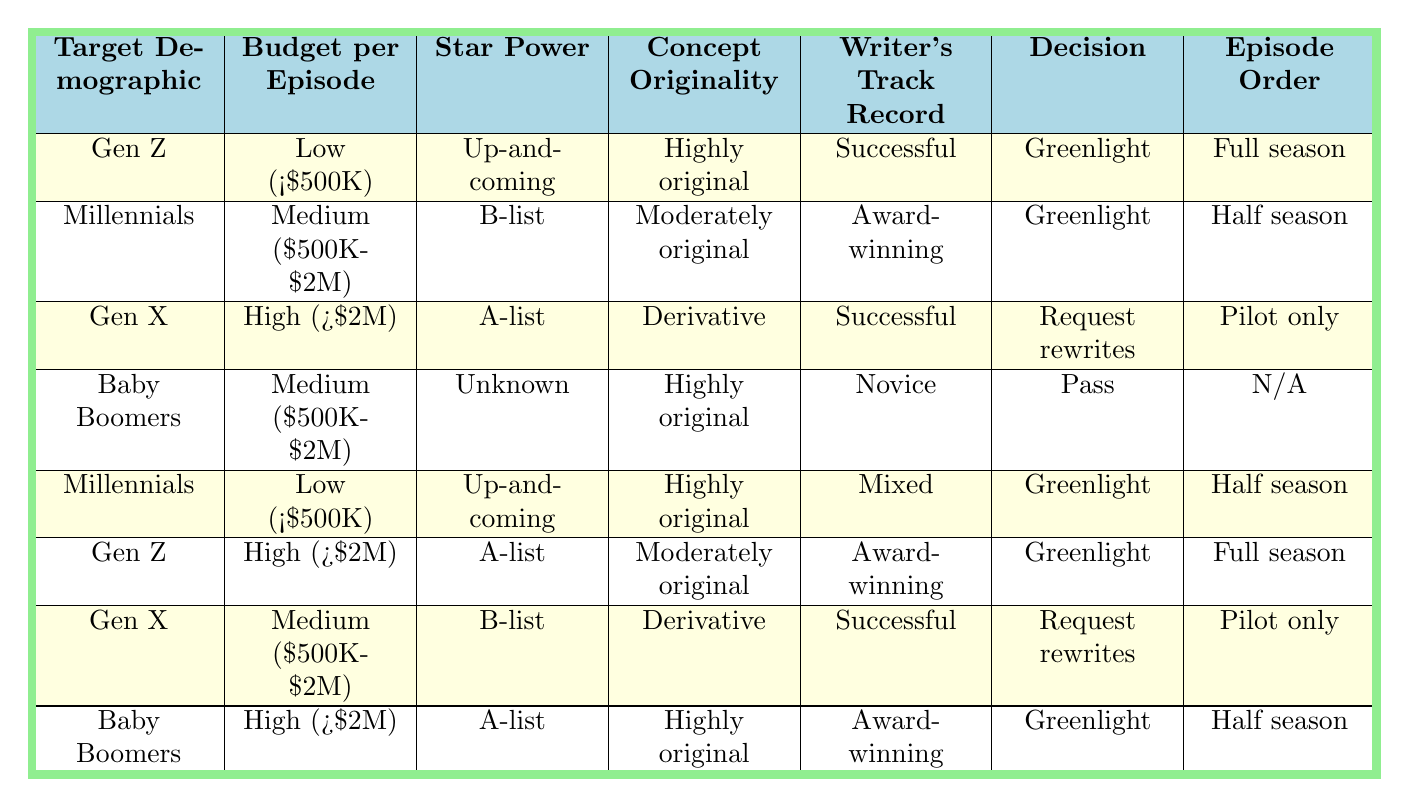What decision was made for comedies targeting Gen Z with a low budget and an up-and-coming star? The table shows that for Gen Z with a low budget, up-and-coming star, highly original concept, and a successful writer's track record, the decision was to greenlight a full season.
Answer: Greenlight, Full season How many different episode orders are associated with the Millennials demographic? By reviewing the table, we see that there are two episode orders associated with Millennials: "Half season" and "Pilot only." Even though the table specifies two different conditions, it points to the same episode order.
Answer: 2 Is there any comedy pilot that received a "Pass" as a decision? The table indicates that there is one situation where Baby Boomers with a medium budget, unknown star power, highly original concept, and novice writer's track record received a pass.
Answer: Yes What is the average budget category of comedies that received a "Greenlight"? Examining the rows for the "Greenlight" decision, we find two "Low," two "Medium," and three "High" budget instances. The average can be calculated as: (2 Low + 2 Medium + 3 High) / 7 = Medium, as the average tends towards the midpoint.
Answer: Medium Which demographic has the most combinations for "Request rewrites" decisions? Looking at the table, we see there are two "Request rewrites" decisions, both related to Gen X: one for a high budget with A-list star power and derivative concept, and the other for a medium budget with B-list star power and derivative concept. Hence, Gen X has the most combinations.
Answer: Gen X How many comedies with a "Highly original" concept received either a "Greenlight" or "Pass" decision? On analyzing the table, we find that four comedies with a highly original concept were greenlit, while one was passed. Therefore, there are five comedies in total with highly original concepts that received either a greenlight or a pass.
Answer: 5 What is the decision for Baby Boomers with a high budget and award-winning writer track record? According to the table, the decision for this category is to greenlight a half season, confirming the power of A-list stars when combined with high originality and accolades.
Answer: Greenlight, Half season Are there any comedies that were given a "Pilot only" episode order? Based on the table, two comedies received a "Pilot only" episode order: one for Gen X with a high budget, A-list star power, and derivative content, and the other for Gen X with a medium budget and B-list star power, which also happened to be derivative.
Answer: Yes 